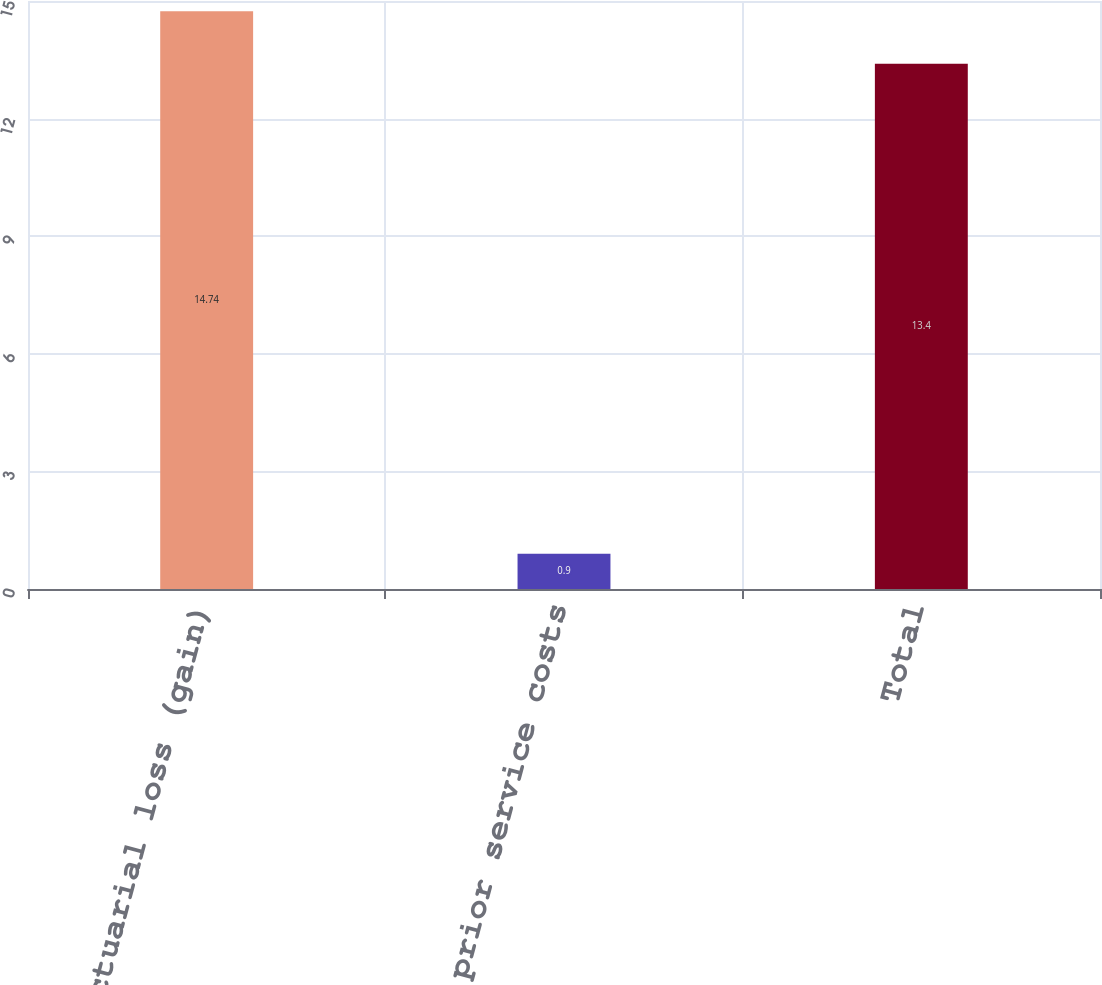<chart> <loc_0><loc_0><loc_500><loc_500><bar_chart><fcel>Net actuarial loss (gain)<fcel>Net prior service costs<fcel>Total<nl><fcel>14.74<fcel>0.9<fcel>13.4<nl></chart> 